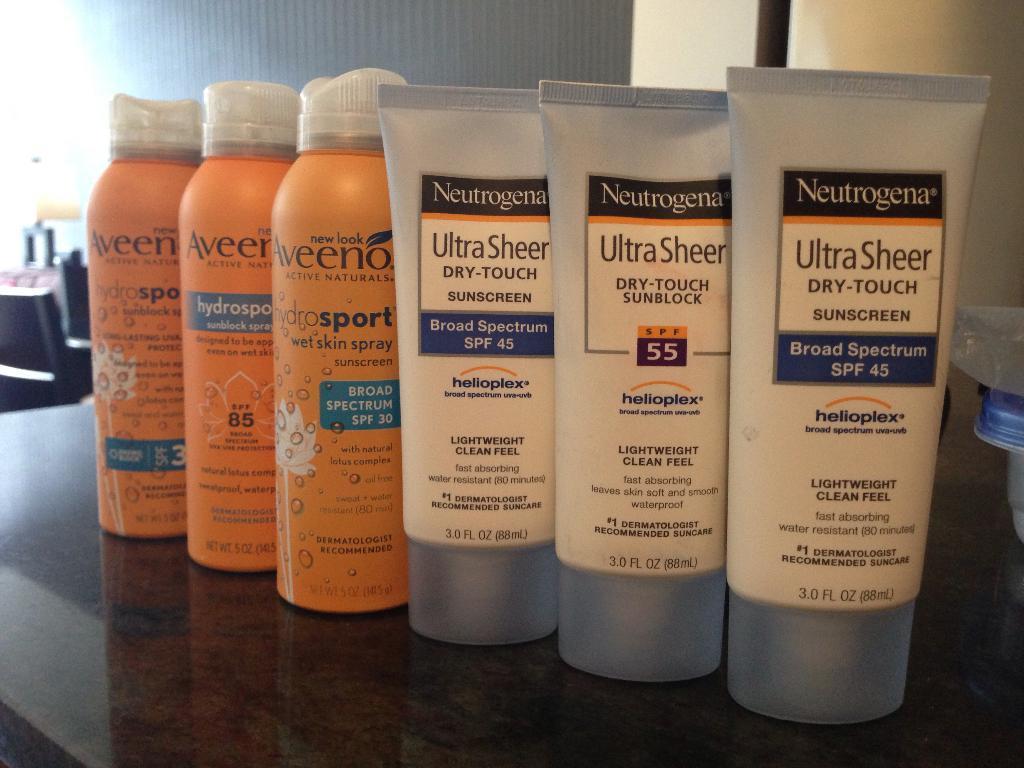Describe this image in one or two sentences. In this image there are three cream tubes , three spray bottles on the table, and in the background there are some objects and a wall. 